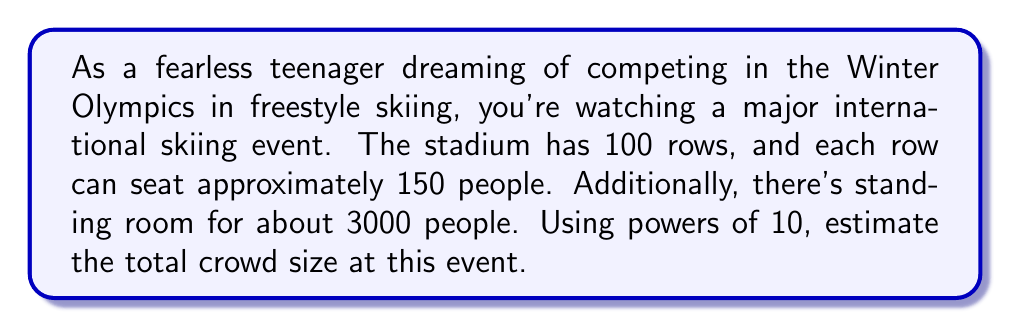Can you answer this question? Let's break this down step-by-step:

1) First, let's calculate the number of seated spectators:
   - Number of rows: 100
   - Approximate number of people per row: 150
   - Total seated spectators: $100 \times 150 = 15,000$

2) Now, let's add the standing spectators:
   - Standing spectators: 3,000
   - Total spectators: $15,000 + 3,000 = 18,000$

3) To estimate this using powers of 10, we need to find the closest power of 10 to 18,000.

4) The powers of 10 are:
   $10^1 = 10$
   $10^2 = 100$
   $10^3 = 1,000$
   $10^4 = 10,000$
   $10^5 = 100,000$

5) 18,000 is between $10^4$ and $10^5$, but it's closer to $10^4$.

6) Therefore, we can estimate the crowd size as approximately $2 \times 10^4$.

This estimation technique using powers of 10 is useful for quickly communicating large numbers in scientific notation or for rough calculations.
Answer: $2 \times 10^4$ spectators 